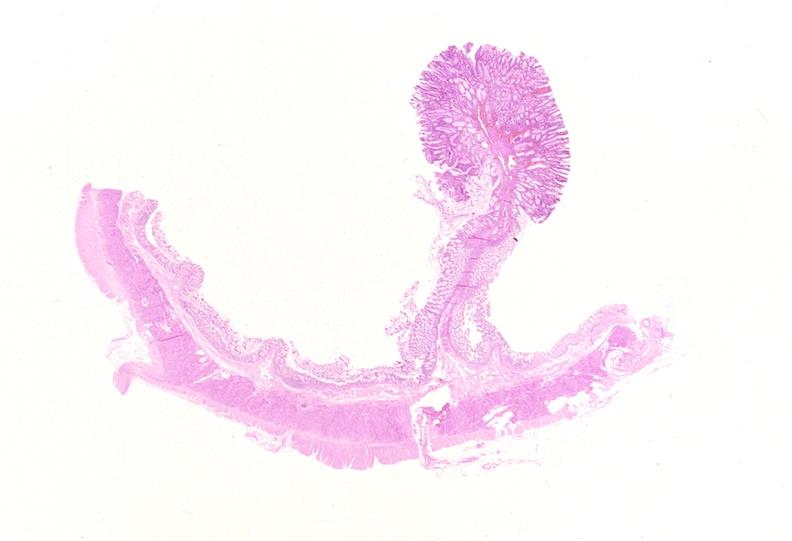what is present?
Answer the question using a single word or phrase. Gastrointestinal 